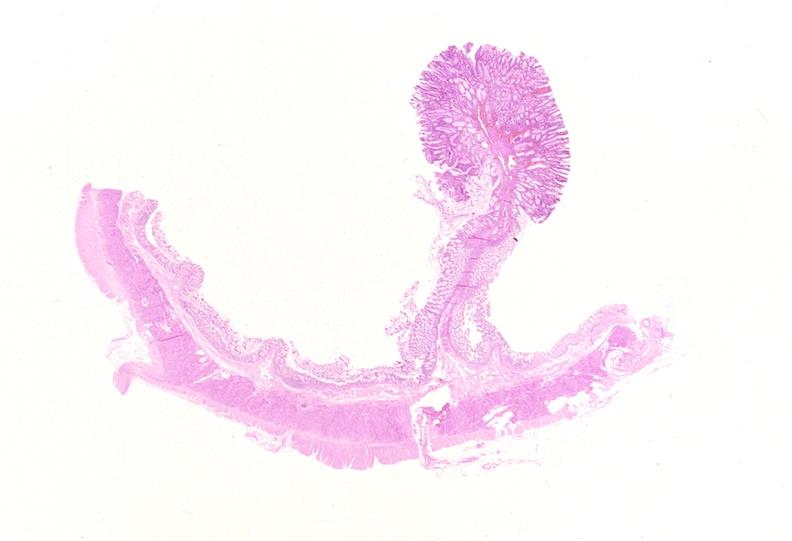what is present?
Answer the question using a single word or phrase. Gastrointestinal 